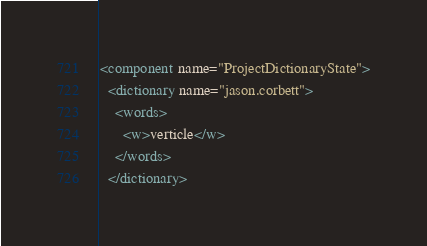<code> <loc_0><loc_0><loc_500><loc_500><_XML_><component name="ProjectDictionaryState">
  <dictionary name="jason.corbett">
    <words>
      <w>verticle</w>
    </words>
  </dictionary></code> 